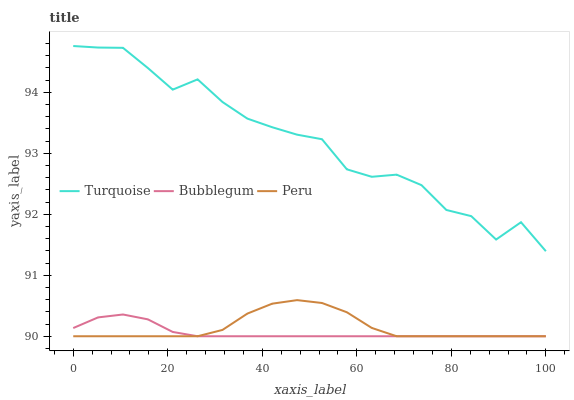Does Bubblegum have the minimum area under the curve?
Answer yes or no. Yes. Does Turquoise have the maximum area under the curve?
Answer yes or no. Yes. Does Peru have the minimum area under the curve?
Answer yes or no. No. Does Peru have the maximum area under the curve?
Answer yes or no. No. Is Bubblegum the smoothest?
Answer yes or no. Yes. Is Turquoise the roughest?
Answer yes or no. Yes. Is Peru the smoothest?
Answer yes or no. No. Is Peru the roughest?
Answer yes or no. No. Does Peru have the lowest value?
Answer yes or no. Yes. Does Turquoise have the highest value?
Answer yes or no. Yes. Does Peru have the highest value?
Answer yes or no. No. Is Bubblegum less than Turquoise?
Answer yes or no. Yes. Is Turquoise greater than Peru?
Answer yes or no. Yes. Does Peru intersect Bubblegum?
Answer yes or no. Yes. Is Peru less than Bubblegum?
Answer yes or no. No. Is Peru greater than Bubblegum?
Answer yes or no. No. Does Bubblegum intersect Turquoise?
Answer yes or no. No. 